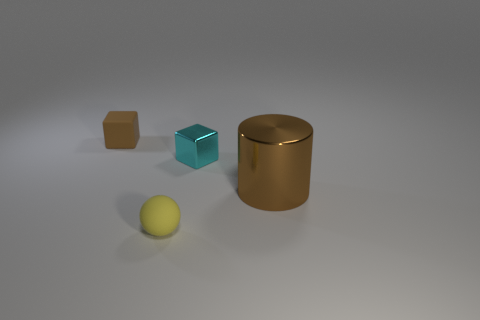Are the objects arranged in any specific pattern? The objects do not seem to follow a specific pattern; they are spread out across the surface randomly, with varying distances between each other. Could these objects represent any real-world concept or idea? One could interpret the objects as a visual metaphor for diversity and individuality, with each object's distinct shape and size symbolizing unique characteristics within a community or group. 